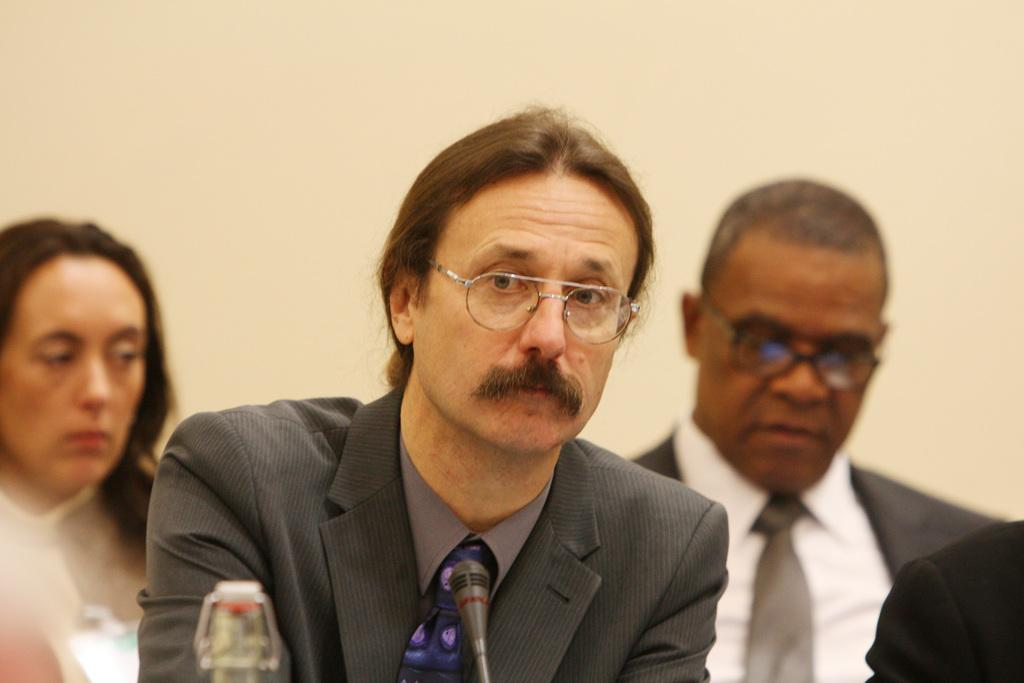What is happening in the image? There is a group of persons sitting in the image. Can you describe the attire of one of the persons? One person is wearing a suit. What object is present in the image that is typically used for amplifying sound? There is a microphone in the image. What can be seen in the background of the image? There is a wall visible in the background of the image. How many boys are sitting in the image? The provided facts do not mention the gender of the persons in the image, so it cannot be determined if there are any boys present. 